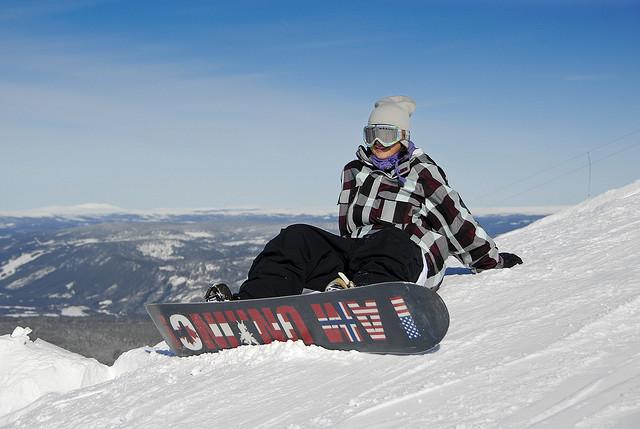What is covering the ground?
Be succinct. Snow. What does the snowboard say?
Write a very short answer. I am uninc. What is the woman riding?
Write a very short answer. Snowboard. 